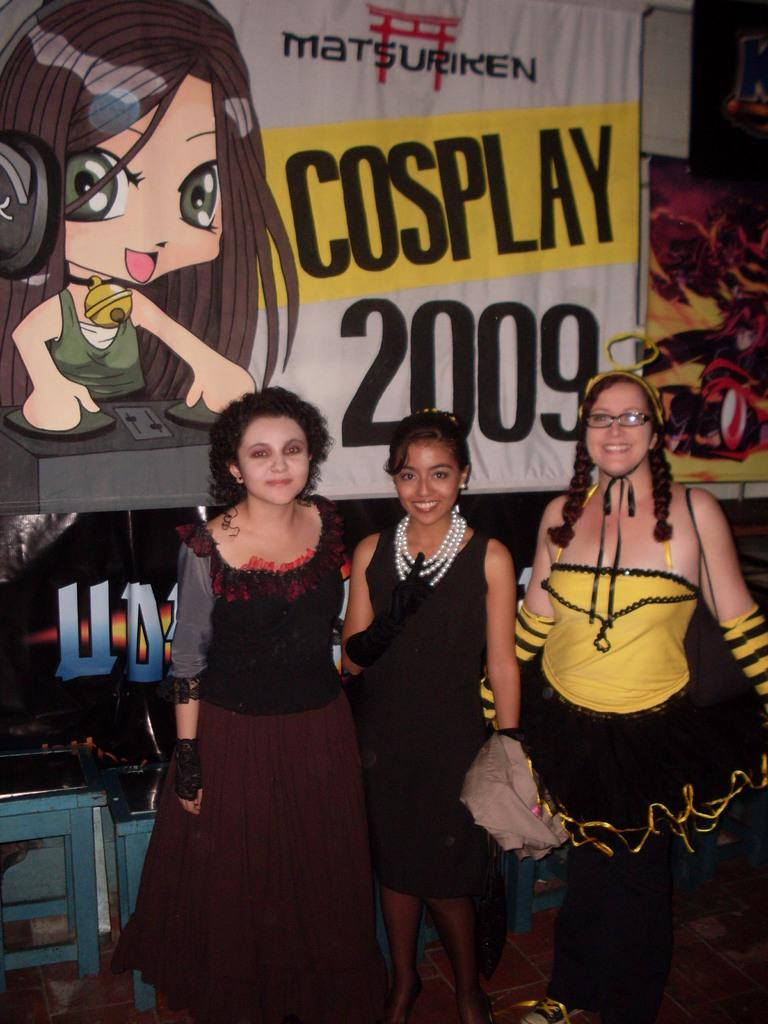How many people are in the image? There are three persons standing in the center of the image. What can be seen in the background of the image? There is a banner in the background of the image. What type of seed is being planted by the persons in the image? There is no seed or planting activity depicted in the image; it features three persons standing in the center and a banner in the background. 